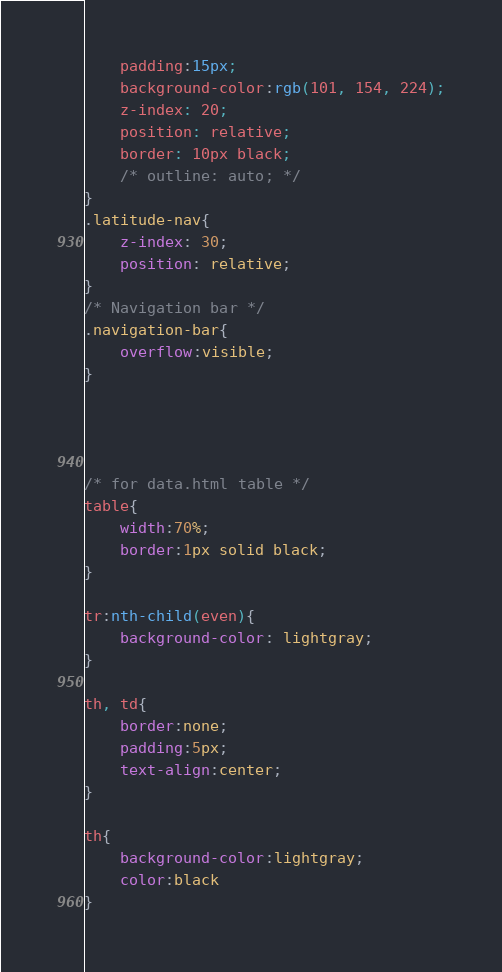<code> <loc_0><loc_0><loc_500><loc_500><_CSS_>    padding:15px;
    background-color:rgb(101, 154, 224);
    z-index: 20;
    position: relative;
    border: 10px black;
    /* outline: auto; */
}
.latitude-nav{
    z-index: 30;
    position: relative;
}
/* Navigation bar */
.navigation-bar{
    overflow:visible;
}




/* for data.html table */
table{
    width:70%;
    border:1px solid black;
}

tr:nth-child(even){
    background-color: lightgray;
}

th, td{
    border:none;
    padding:5px;
    text-align:center;
}

th{
    background-color:lightgray;
    color:black
}</code> 